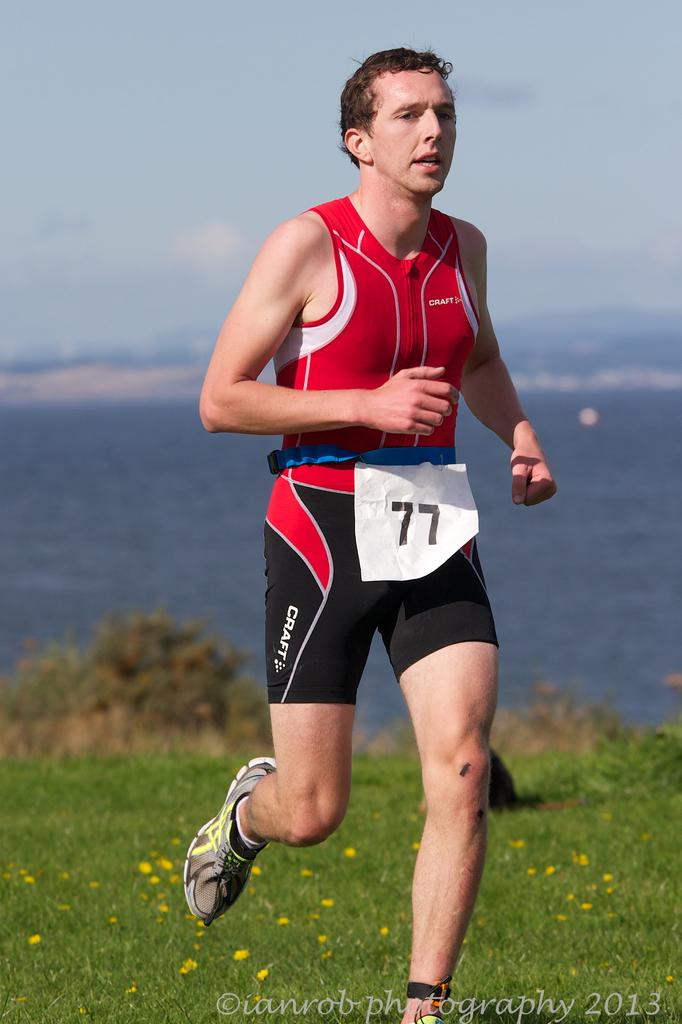<image>
Provide a brief description of the given image. a man that is running with the number 77 